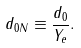Convert formula to latex. <formula><loc_0><loc_0><loc_500><loc_500>d _ { 0 N } \equiv \frac { d _ { 0 } } { Y _ { e } } .</formula> 